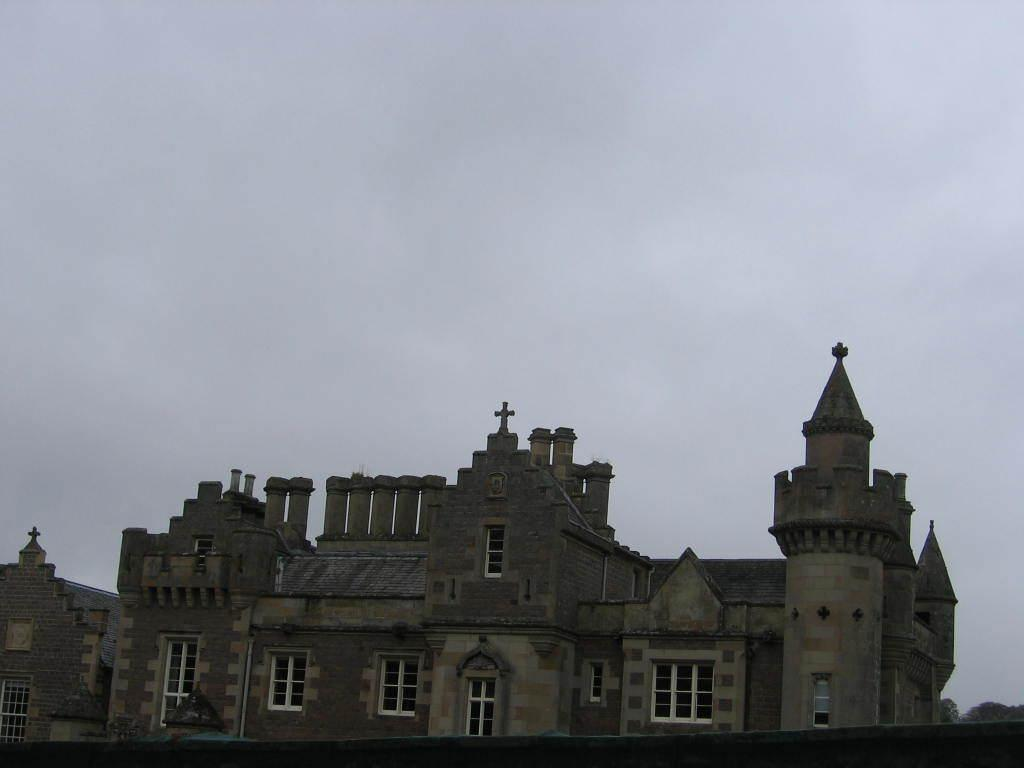What type of structure is present in the image? There is a building in the image. What can be seen in the sky at the top of the image? The sky is visible at the top of the image. What type of grape is being taught in the class depicted in the image? There is no class or grape present in the image; it only features a building and the sky. 